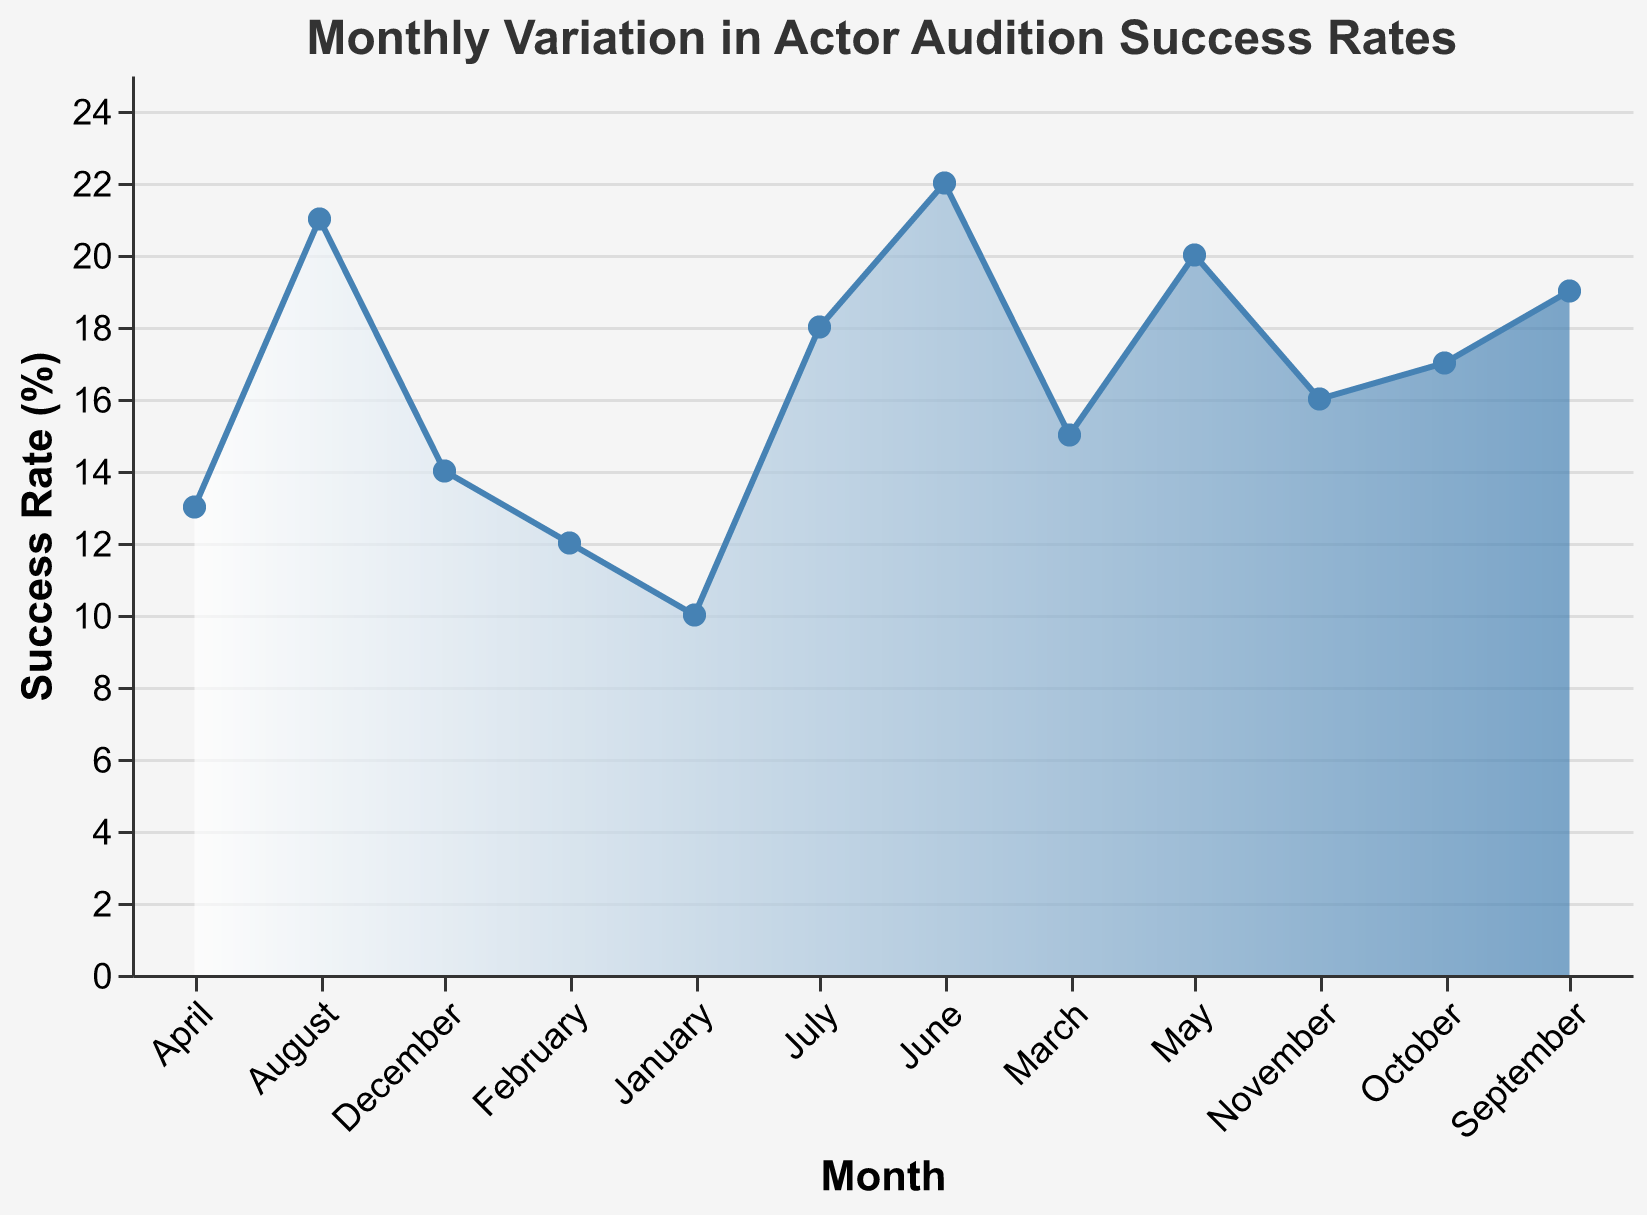what's the title of the figure? The title of the figure is typically found at the top and provides a summary of the visual information presented. In this case, it reads "Monthly Variation in Actor Audition Success Rates".
Answer: Monthly Variation in Actor Audition Success Rates what is the success rate in June? Locate June on the x-axis and trace upwards to find the corresponding point on the area chart, which indicates the value on the y-axis. The success rate in June reads 22%.
Answer: 22% Which month has the highest success rate? Look for the highest point on the area chart. Trace down to the x-axis to see which month it corresponds to. The highest point falls in June, indicating the highest success rate.
Answer: June What is the difference between the success rates in May and December? Note the success rate for May (20%) and December (14%). Subtract the success rate of December from that of May: 20 - 14 = 6%.
Answer: 6% In which month does the success rate first exceed 15%? Look at the success rate on the y-axis and trace across to see which month exceeds 15% for the first time. March shows a success rate of 15%, and April exceeds it with 13%.
Answer: March What is the average success rate for the first quarter of the year (January to March)? Identify the success rates for January (10%), February (12%), and March (15%). Add these values and divide by 3 to get the average. (10 + 12 + 15) / 3 = 37 / 3 ≈ 12.33%.
Answer: ≈ 12.33% Which months have a success rate below 15%? Look at the y-axis and check all months corresponding to a success rate below 15%. January, February, and December all have success rates below 15%.
Answer: January, February, December What trends can you observe in the success rates from January to June? Examine the area chart from January to June noting the rise and fall of the success rates. It generally shows an increasing trend with fluctuations in April (dropping to 13%).
Answer: Increasing trend with fluctuations When does the success rate peak again after July? Look at the chart to find the highest success rate after July. The peak observed in August with a success rate of 21%.
Answer: August 